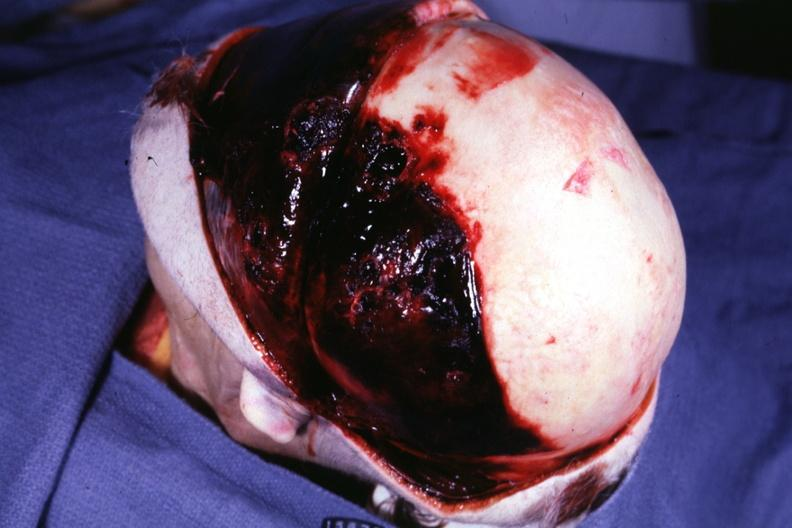s temporal muscle hemorrhage present?
Answer the question using a single word or phrase. Yes 